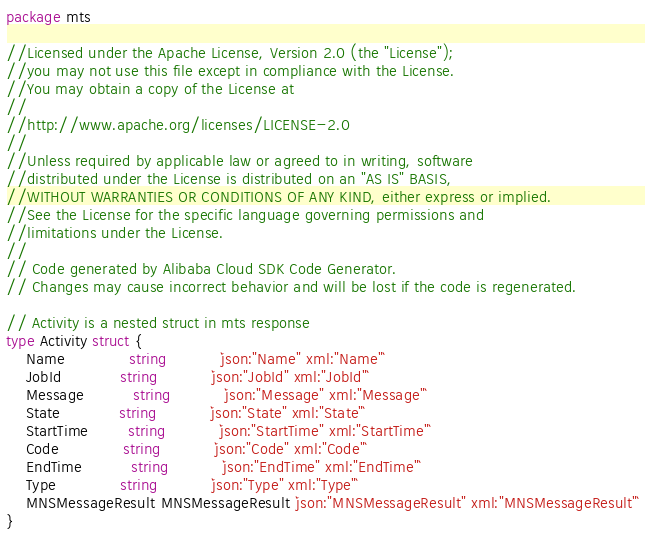<code> <loc_0><loc_0><loc_500><loc_500><_Go_>package mts

//Licensed under the Apache License, Version 2.0 (the "License");
//you may not use this file except in compliance with the License.
//You may obtain a copy of the License at
//
//http://www.apache.org/licenses/LICENSE-2.0
//
//Unless required by applicable law or agreed to in writing, software
//distributed under the License is distributed on an "AS IS" BASIS,
//WITHOUT WARRANTIES OR CONDITIONS OF ANY KIND, either express or implied.
//See the License for the specific language governing permissions and
//limitations under the License.
//
// Code generated by Alibaba Cloud SDK Code Generator.
// Changes may cause incorrect behavior and will be lost if the code is regenerated.

// Activity is a nested struct in mts response
type Activity struct {
	Name             string           `json:"Name" xml:"Name"`
	JobId            string           `json:"JobId" xml:"JobId"`
	Message          string           `json:"Message" xml:"Message"`
	State            string           `json:"State" xml:"State"`
	StartTime        string           `json:"StartTime" xml:"StartTime"`
	Code             string           `json:"Code" xml:"Code"`
	EndTime          string           `json:"EndTime" xml:"EndTime"`
	Type             string           `json:"Type" xml:"Type"`
	MNSMessageResult MNSMessageResult `json:"MNSMessageResult" xml:"MNSMessageResult"`
}
</code> 